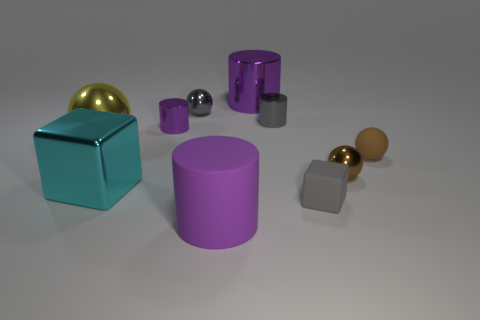What is the material of the tiny cylinder that is the same color as the small cube?
Provide a short and direct response. Metal. What size is the metal ball that is the same color as the tiny cube?
Provide a succinct answer. Small. Is the number of purple metallic objects greater than the number of small red metallic spheres?
Your answer should be very brief. Yes. Is the color of the large metal cylinder the same as the shiny cube?
Your answer should be compact. No. What number of things are tiny green shiny things or metallic things that are behind the large sphere?
Provide a succinct answer. 4. What number of other things are there of the same shape as the brown shiny object?
Offer a terse response. 3. Are there fewer gray metal objects that are on the left side of the large metallic cylinder than tiny gray balls that are on the left side of the small gray metal cylinder?
Your answer should be very brief. No. Is there any other thing that is the same material as the gray cylinder?
Your response must be concise. Yes. There is a small brown thing that is made of the same material as the cyan block; what shape is it?
Give a very brief answer. Sphere. Are there any other things of the same color as the rubber cylinder?
Offer a terse response. Yes. 